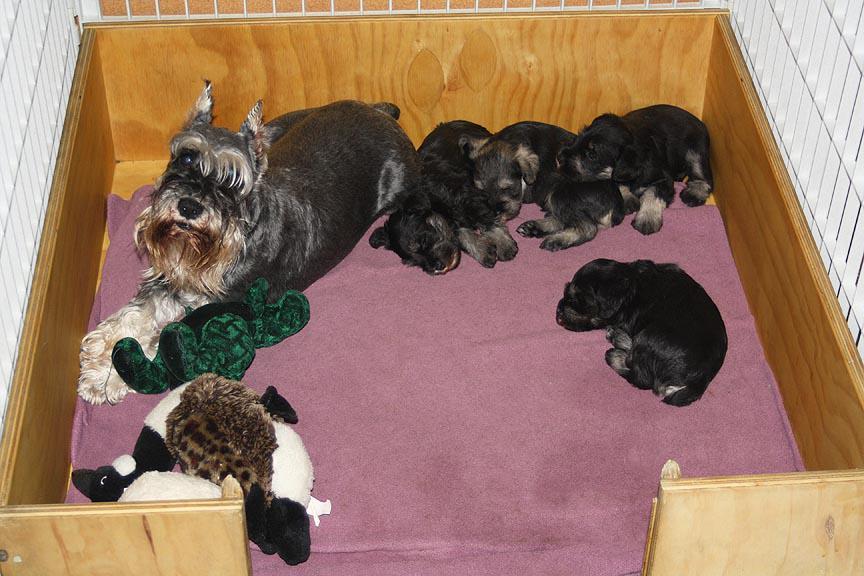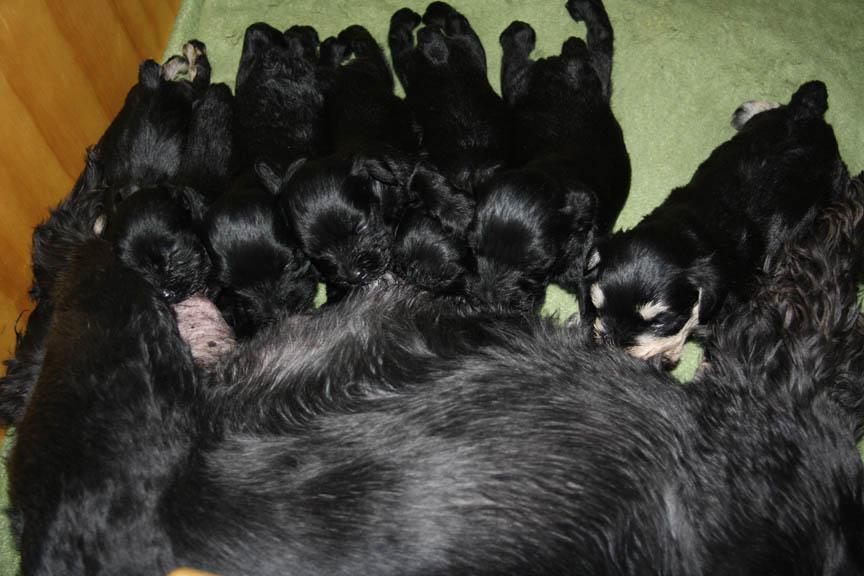The first image is the image on the left, the second image is the image on the right. For the images displayed, is the sentence "At least one image in the set features 4 or more puppies, laying with their mother." factually correct? Answer yes or no. Yes. The first image is the image on the left, the second image is the image on the right. For the images shown, is this caption "There are four or more puppies sleeping together in each image" true? Answer yes or no. Yes. 